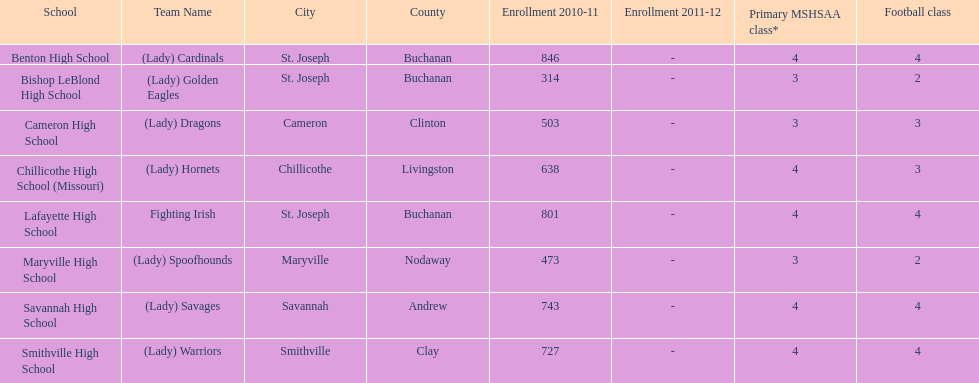Does lafayette high school or benton high school have green and grey as their colors? Lafayette High School. 